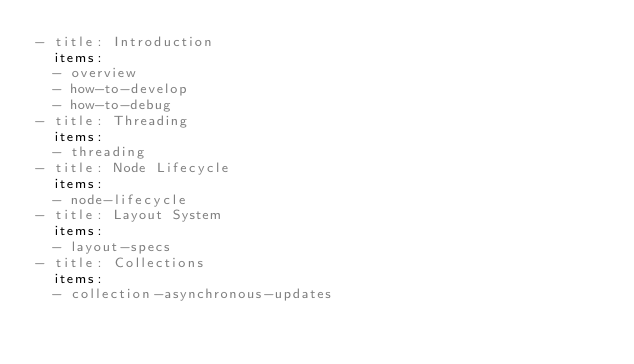<code> <loc_0><loc_0><loc_500><loc_500><_YAML_>- title: Introduction
  items:
  - overview
  - how-to-develop
  - how-to-debug
- title: Threading
  items:
  - threading
- title: Node Lifecycle
  items:
  - node-lifecycle
- title: Layout System
  items:
  - layout-specs
- title: Collections
  items:
  - collection-asynchronous-updates
</code> 